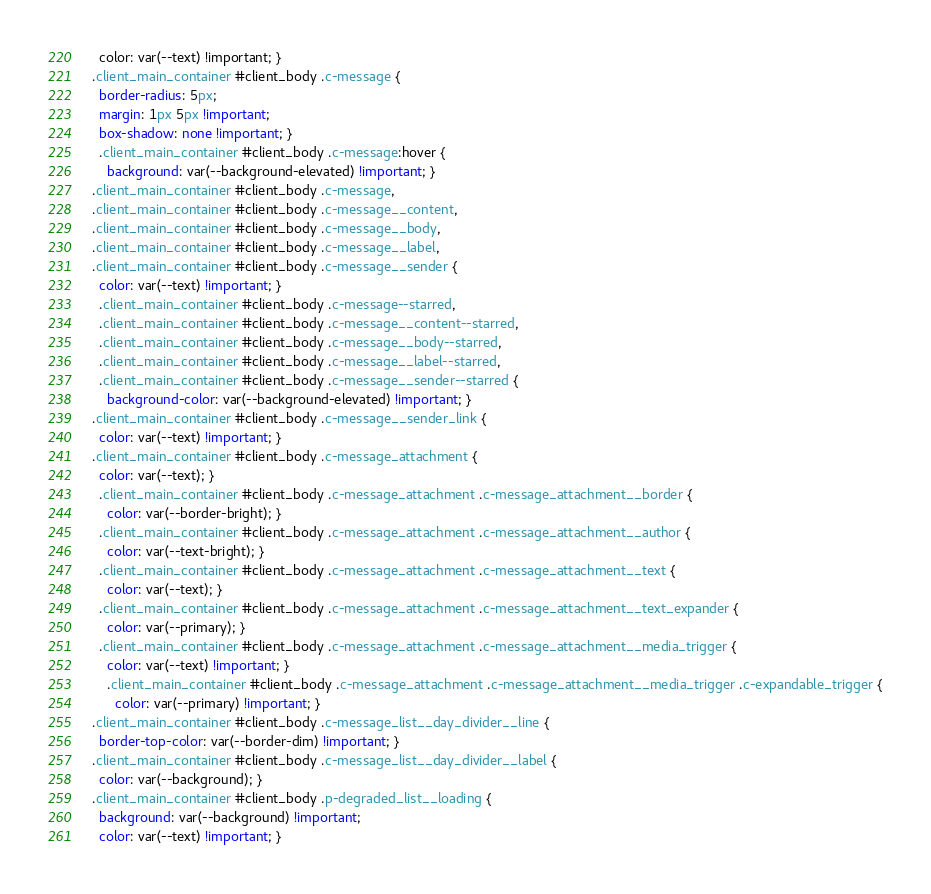Convert code to text. <code><loc_0><loc_0><loc_500><loc_500><_CSS_>    color: var(--text) !important; }
  .client_main_container #client_body .c-message {
    border-radius: 5px;
    margin: 1px 5px !important;
    box-shadow: none !important; }
    .client_main_container #client_body .c-message:hover {
      background: var(--background-elevated) !important; }
  .client_main_container #client_body .c-message,
  .client_main_container #client_body .c-message__content,
  .client_main_container #client_body .c-message__body,
  .client_main_container #client_body .c-message__label,
  .client_main_container #client_body .c-message__sender {
    color: var(--text) !important; }
    .client_main_container #client_body .c-message--starred,
    .client_main_container #client_body .c-message__content--starred,
    .client_main_container #client_body .c-message__body--starred,
    .client_main_container #client_body .c-message__label--starred,
    .client_main_container #client_body .c-message__sender--starred {
      background-color: var(--background-elevated) !important; }
  .client_main_container #client_body .c-message__sender_link {
    color: var(--text) !important; }
  .client_main_container #client_body .c-message_attachment {
    color: var(--text); }
    .client_main_container #client_body .c-message_attachment .c-message_attachment__border {
      color: var(--border-bright); }
    .client_main_container #client_body .c-message_attachment .c-message_attachment__author {
      color: var(--text-bright); }
    .client_main_container #client_body .c-message_attachment .c-message_attachment__text {
      color: var(--text); }
    .client_main_container #client_body .c-message_attachment .c-message_attachment__text_expander {
      color: var(--primary); }
    .client_main_container #client_body .c-message_attachment .c-message_attachment__media_trigger {
      color: var(--text) !important; }
      .client_main_container #client_body .c-message_attachment .c-message_attachment__media_trigger .c-expandable_trigger {
        color: var(--primary) !important; }
  .client_main_container #client_body .c-message_list__day_divider__line {
    border-top-color: var(--border-dim) !important; }
  .client_main_container #client_body .c-message_list__day_divider__label {
    color: var(--background); }
  .client_main_container #client_body .p-degraded_list__loading {
    background: var(--background) !important;
    color: var(--text) !important; }</code> 